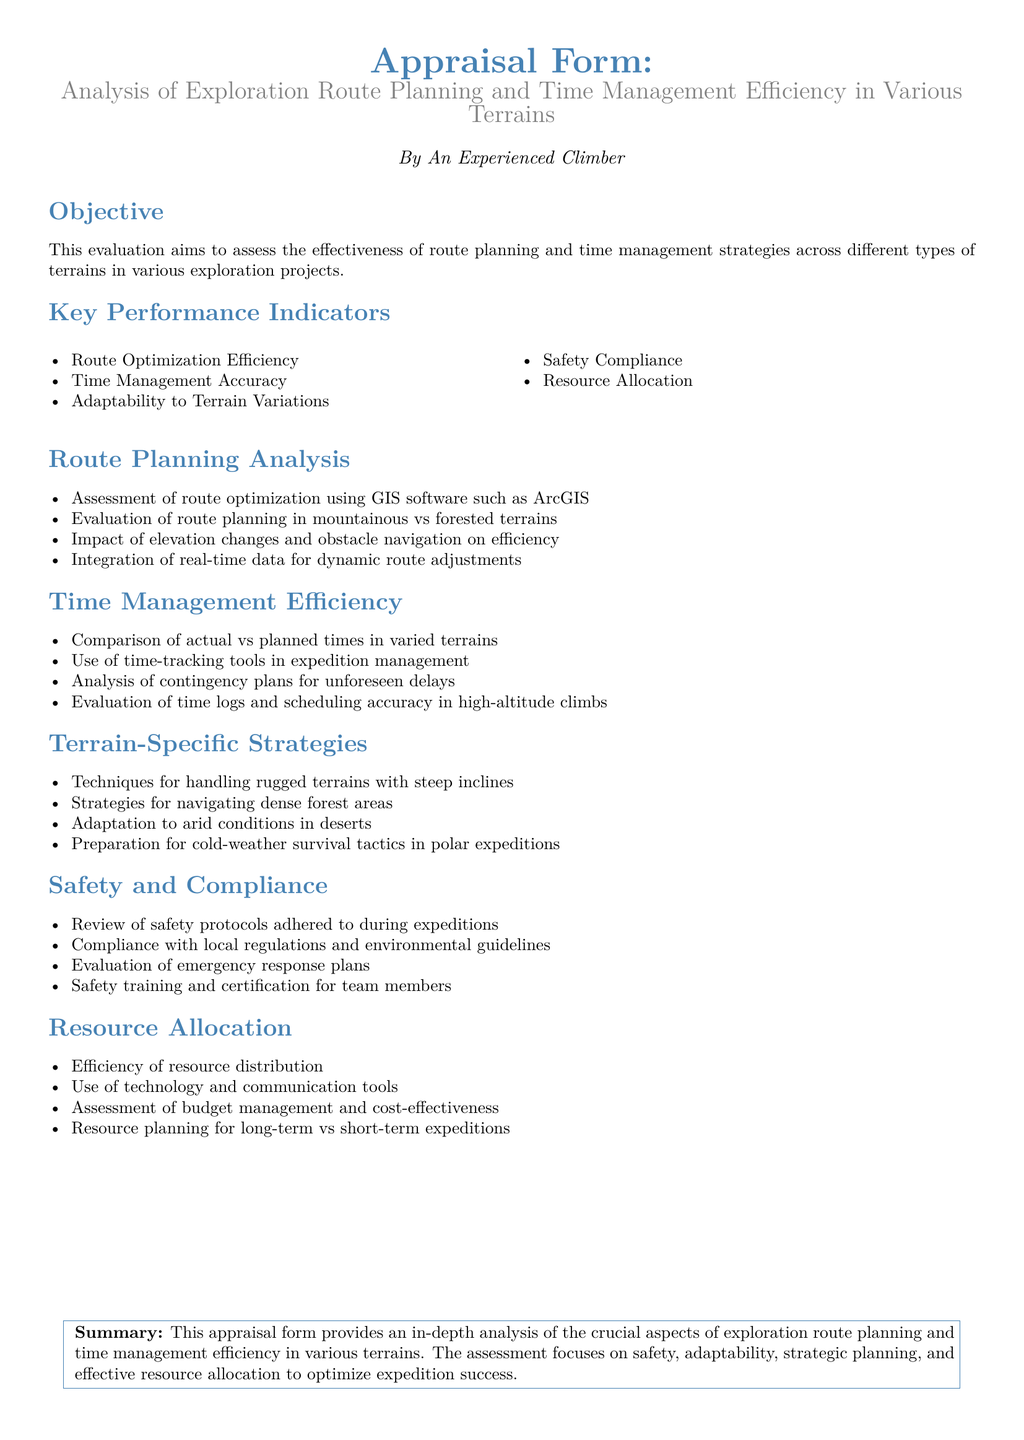What is the main objective of the appraisal? The main objective is to assess the effectiveness of route planning and time management strategies across different types of terrains in various exploration projects.
Answer: Assess the effectiveness of route planning and time management strategies What software is mentioned for route optimization? The document states that GIS software such as ArcGIS is used for route optimization.
Answer: ArcGIS Name one of the key performance indicators. The document lists route optimization efficiency as one of the key performance indicators.
Answer: Route Optimization Efficiency Which terrain requires adaptation to arid conditions? The appraisal indicates that adaptation to arid conditions is necessary in deserts.
Answer: Deserts What is compared in the time management efficiency section? The section compares actual vs planned times in varied terrains.
Answer: Actual vs planned times How are emergency responses evaluated? The evaluation of emergency responses is based on emergency response plans.
Answer: Emergency response plans What efficiency is discussed under resource allocation? The document discusses the efficiency of resource distribution under resource allocation.
Answer: Resource distribution What type of terrains does the document evaluate besides mountainous? The appraisal evaluates route planning in forested terrains as well.
Answer: Forested terrains What color represents the heading in the document? The color representing the heading in the document is mountain blue.
Answer: Mountain blue 